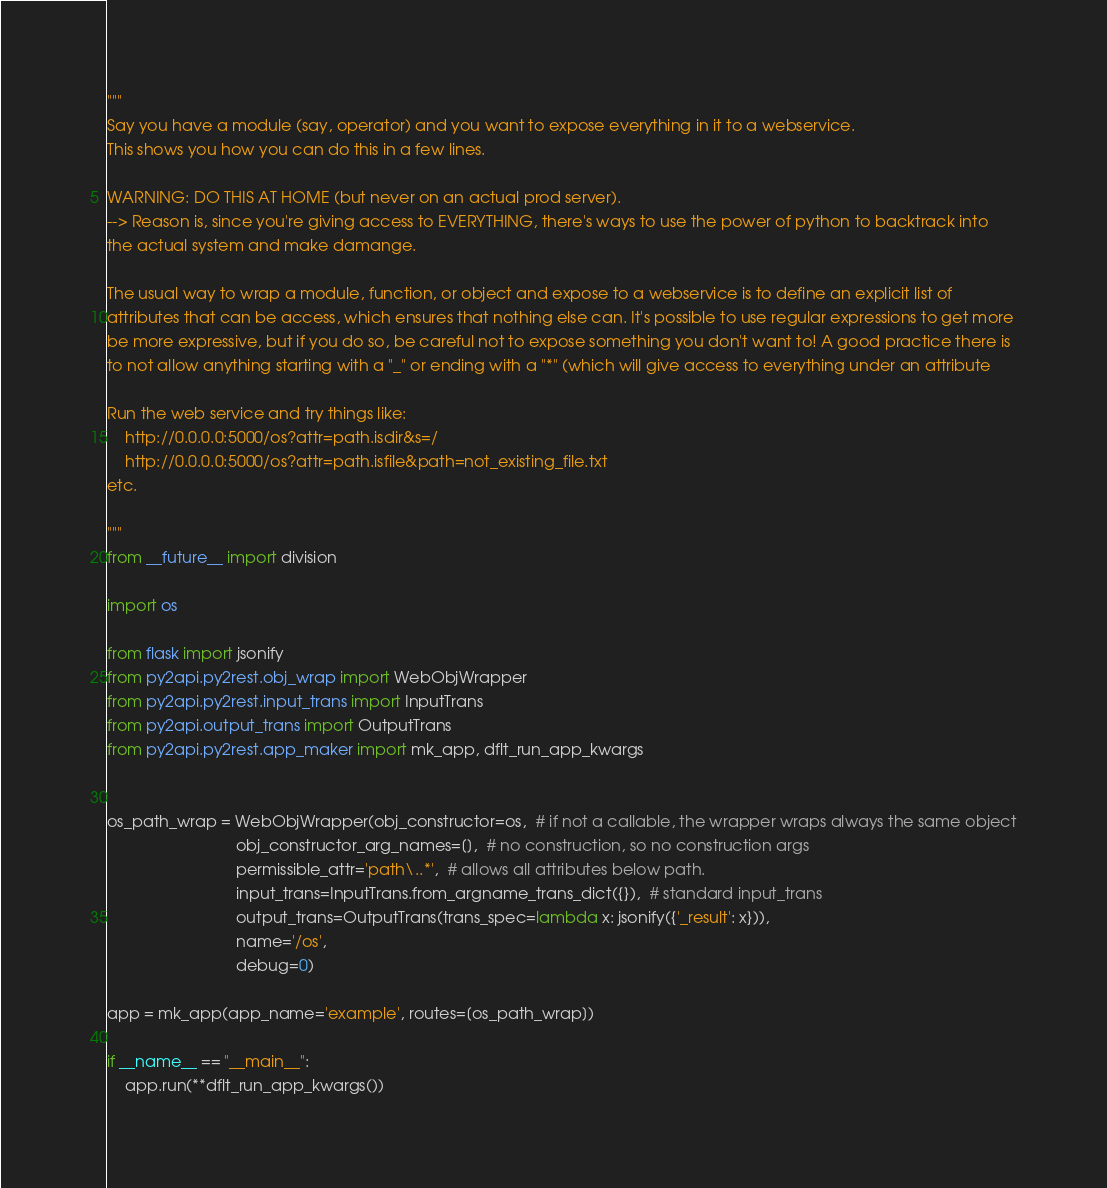<code> <loc_0><loc_0><loc_500><loc_500><_Python_>"""
Say you have a module (say, operator) and you want to expose everything in it to a webservice.
This shows you how you can do this in a few lines.

WARNING: DO THIS AT HOME (but never on an actual prod server).
--> Reason is, since you're giving access to EVERYTHING, there's ways to use the power of python to backtrack into
the actual system and make damange.

The usual way to wrap a module, function, or object and expose to a webservice is to define an explicit list of
attributes that can be access, which ensures that nothing else can. It's possible to use regular expressions to get more
be more expressive, but if you do so, be careful not to expose something you don't want to! A good practice there is
to not allow anything starting with a "_" or ending with a "*" (which will give access to everything under an attribute

Run the web service and try things like:
    http://0.0.0.0:5000/os?attr=path.isdir&s=/
    http://0.0.0.0:5000/os?attr=path.isfile&path=not_existing_file.txt
etc.

"""
from __future__ import division

import os

from flask import jsonify
from py2api.py2rest.obj_wrap import WebObjWrapper
from py2api.py2rest.input_trans import InputTrans
from py2api.output_trans import OutputTrans
from py2api.py2rest.app_maker import mk_app, dflt_run_app_kwargs


os_path_wrap = WebObjWrapper(obj_constructor=os,  # if not a callable, the wrapper wraps always the same object
                             obj_constructor_arg_names=[],  # no construction, so no construction args
                             permissible_attr='path\..*',  # allows all attributes below path.
                             input_trans=InputTrans.from_argname_trans_dict({}),  # standard input_trans
                             output_trans=OutputTrans(trans_spec=lambda x: jsonify({'_result': x})),
                             name='/os',
                             debug=0)

app = mk_app(app_name='example', routes=[os_path_wrap])

if __name__ == "__main__":
    app.run(**dflt_run_app_kwargs())
</code> 